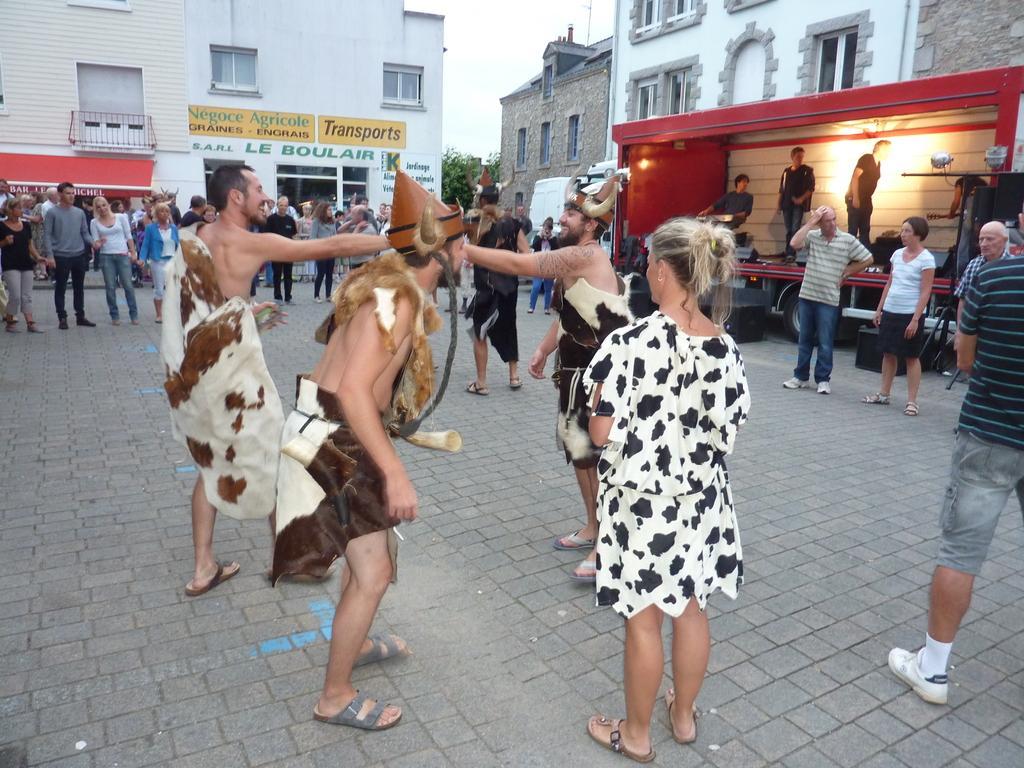Could you give a brief overview of what you see in this image? In this image I can see few people with the costumes. To the right I can see the speakers and I can see few people are standing in the truck. In the background I can see the group of people with different color dresses and there are the buildings with boards and the windows, trees and the sky. 